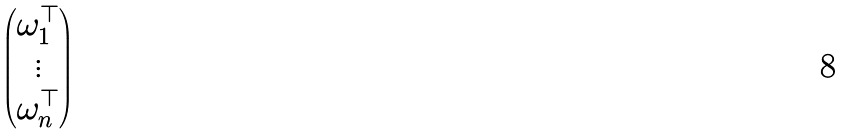<formula> <loc_0><loc_0><loc_500><loc_500>\begin{pmatrix} \omega _ { 1 } ^ { \top } \\ \vdots \\ \omega _ { n } ^ { \top } \end{pmatrix}</formula> 